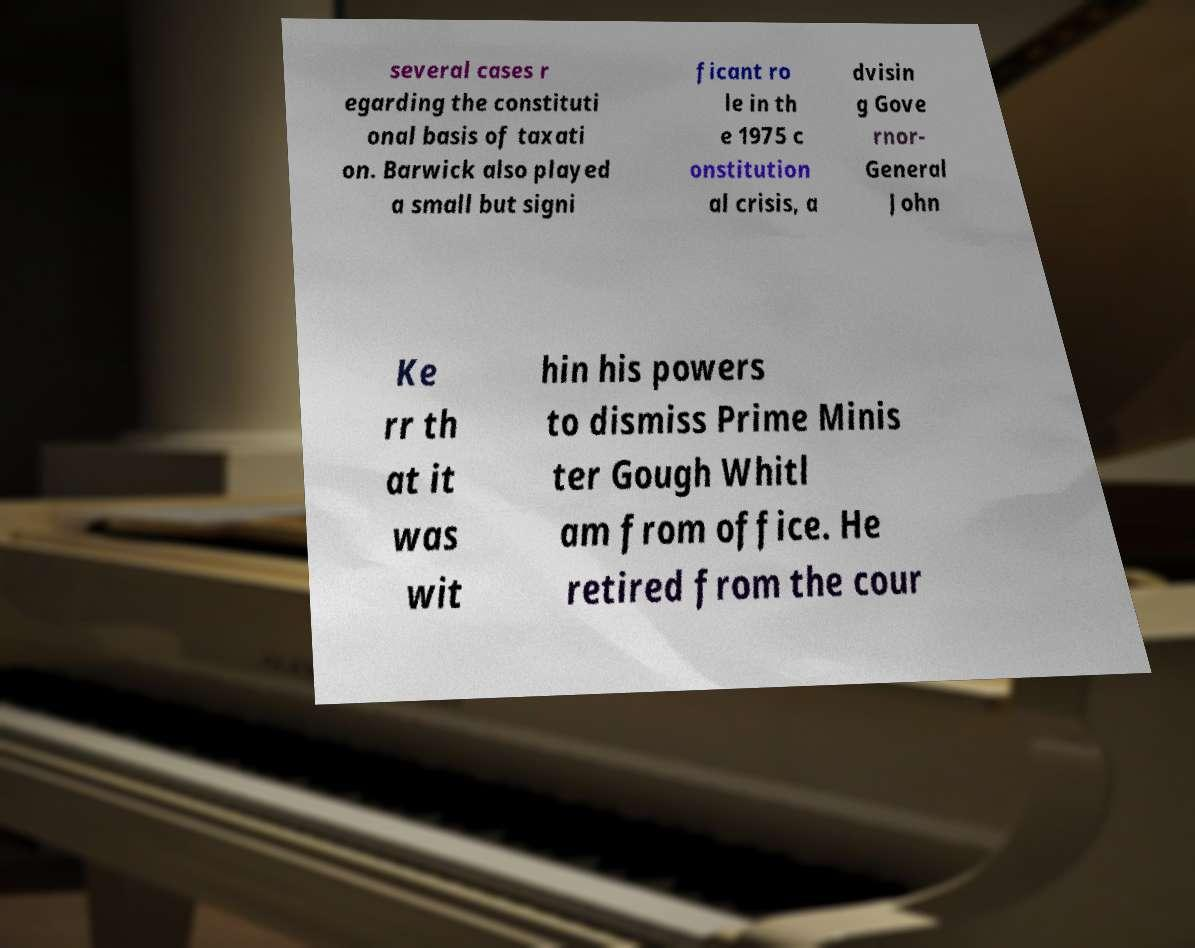Can you accurately transcribe the text from the provided image for me? several cases r egarding the constituti onal basis of taxati on. Barwick also played a small but signi ficant ro le in th e 1975 c onstitution al crisis, a dvisin g Gove rnor- General John Ke rr th at it was wit hin his powers to dismiss Prime Minis ter Gough Whitl am from office. He retired from the cour 